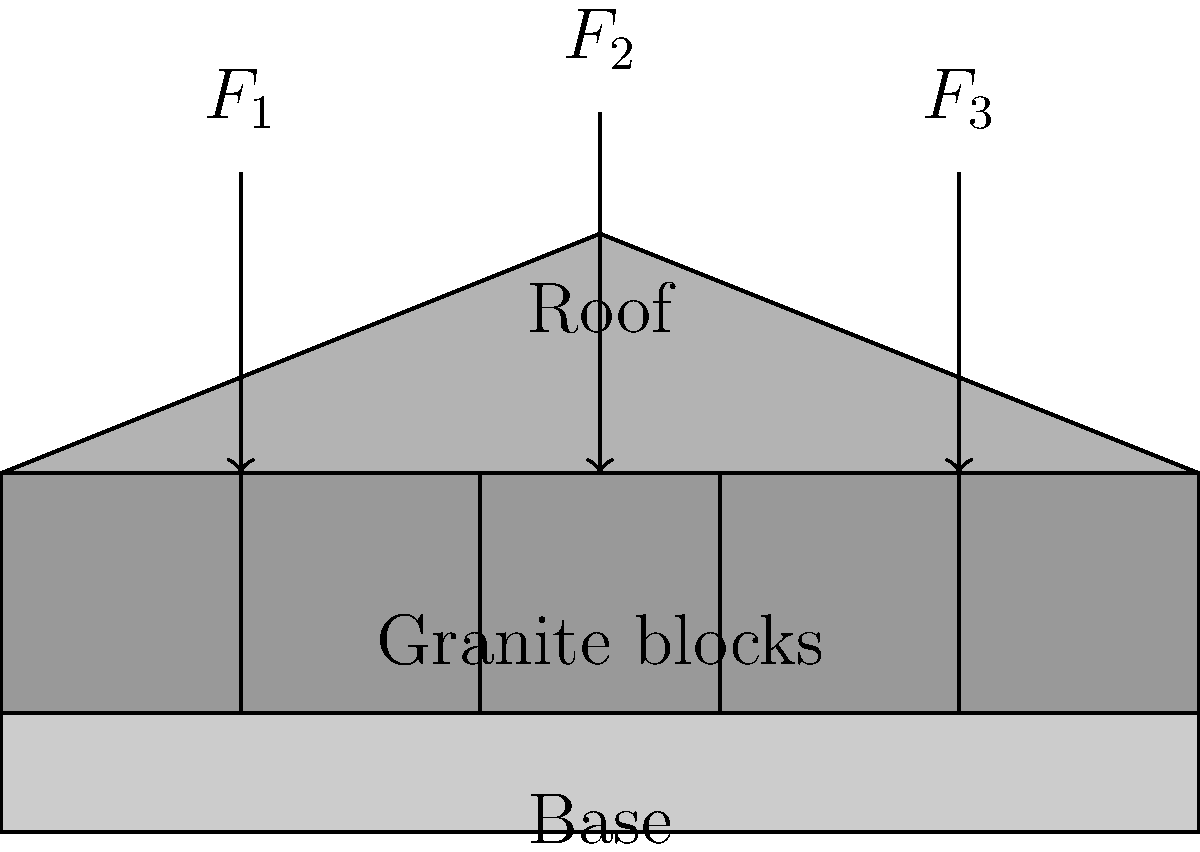Consider the schematic representation of Plymouth Rock's portico, constructed with granite blocks. If the total weight of the roof and additional loads is 15,000 lbs, distributed as shown by forces $F_1$, $F_2$, and $F_3$, with $F_2 = 2F_1 = 2F_3$, what is the load-bearing capacity required for each granite block to safely support this structure? Let's approach this step-by-step:

1) First, we need to determine the distribution of forces:
   Let $F_1 = F_3 = x$ and $F_2 = 2x$

2) The total force is 15,000 lbs, so:
   $F_1 + F_2 + F_3 = 15,000$
   $x + 2x + x = 15,000$
   $4x = 15,000$
   $x = 3,750$

3) Therefore:
   $F_1 = F_3 = 3,750$ lbs
   $F_2 = 7,500$ lbs

4) There are 5 granite blocks shown in the schematic. To distribute the load evenly and safely, each block should be capable of bearing the total load divided by the number of blocks:

   Load per block = Total load / Number of blocks
                  = $15,000 / 5$
                  = $3,000$ lbs

5) However, for safety reasons, we typically apply a factor of safety. In structural engineering, a common factor of safety is 1.5. Applying this:

   Safe load-bearing capacity per block = $3,000 * 1.5 = 4,500$ lbs

This capacity ensures that each block can safely support more than its share of the distributed load, accounting for potential uneven load distribution and providing a safety margin.
Answer: 4,500 lbs 